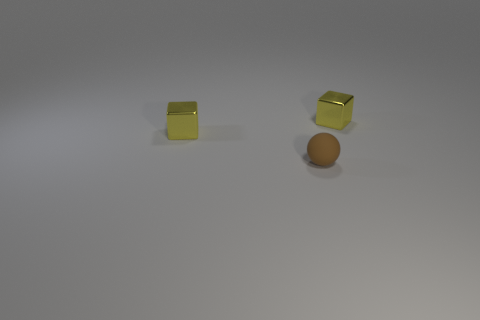Add 2 small yellow shiny cubes. How many objects exist? 5 Subtract all balls. How many objects are left? 2 Add 1 spheres. How many spheres are left? 2 Add 2 tiny brown rubber things. How many tiny brown rubber things exist? 3 Subtract 0 green cylinders. How many objects are left? 3 Subtract all purple matte blocks. Subtract all small spheres. How many objects are left? 2 